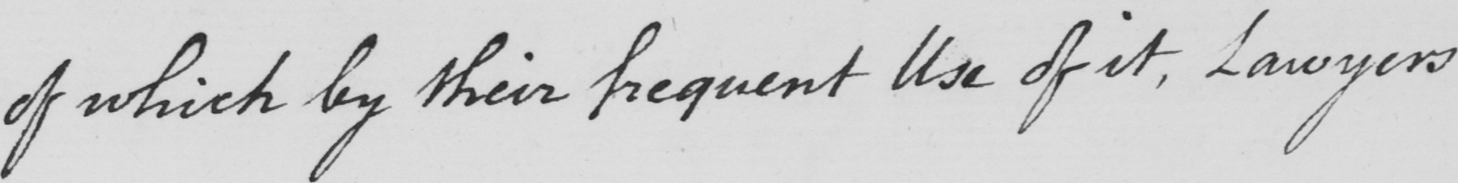What text is written in this handwritten line? of which by their frequent Use of it , Lawyers 